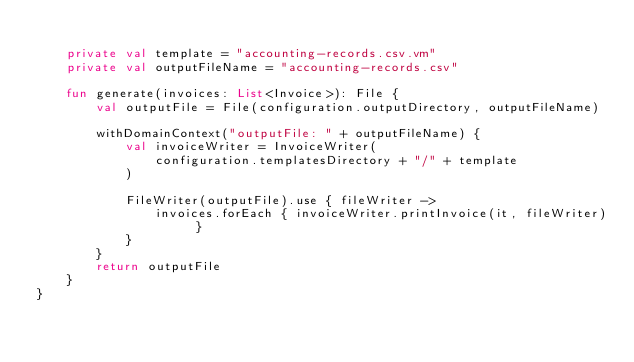<code> <loc_0><loc_0><loc_500><loc_500><_Kotlin_>
    private val template = "accounting-records.csv.vm"
    private val outputFileName = "accounting-records.csv"

    fun generate(invoices: List<Invoice>): File {
        val outputFile = File(configuration.outputDirectory, outputFileName)

        withDomainContext("outputFile: " + outputFileName) {
            val invoiceWriter = InvoiceWriter(
                configuration.templatesDirectory + "/" + template
            )

            FileWriter(outputFile).use { fileWriter ->
                invoices.forEach { invoiceWriter.printInvoice(it, fileWriter) }
            }
        }
        return outputFile
    }
}
</code> 